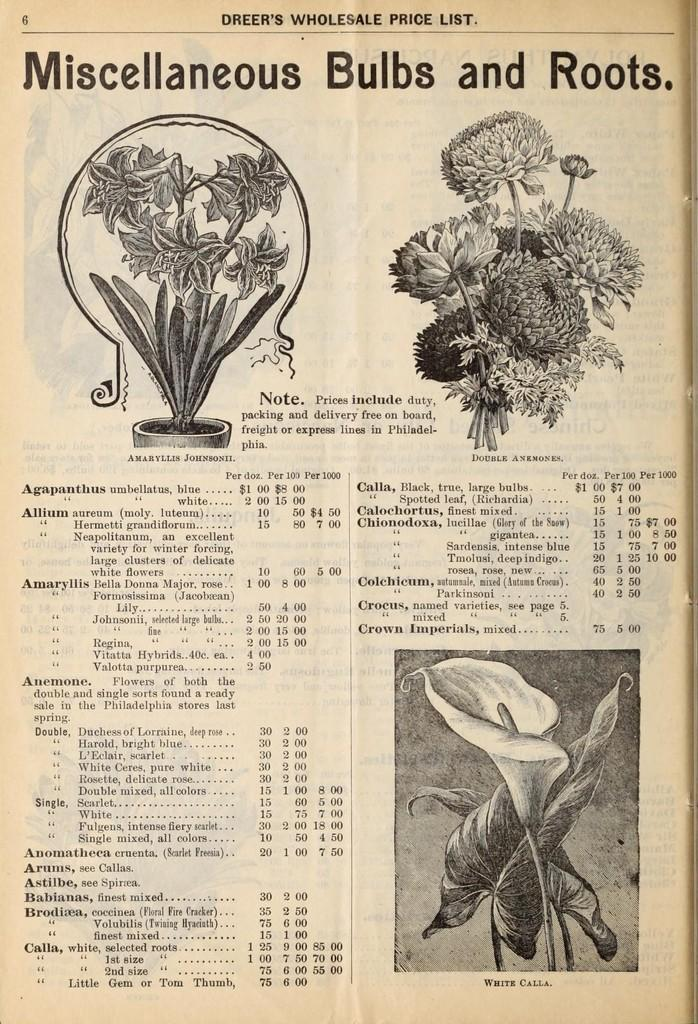What is the main topic of the article in the image? The article in the image is about buds and roots. Can you describe the bud in the image? Yes, there is a bud at the bottom of the image. What is located at the top of the image? There are flowers at the top of the image. Where is the script in the image? The script is on the left side bottom of the image. How many legs can be seen supporting the cork in the image? There is no cork or legs present in the image. 